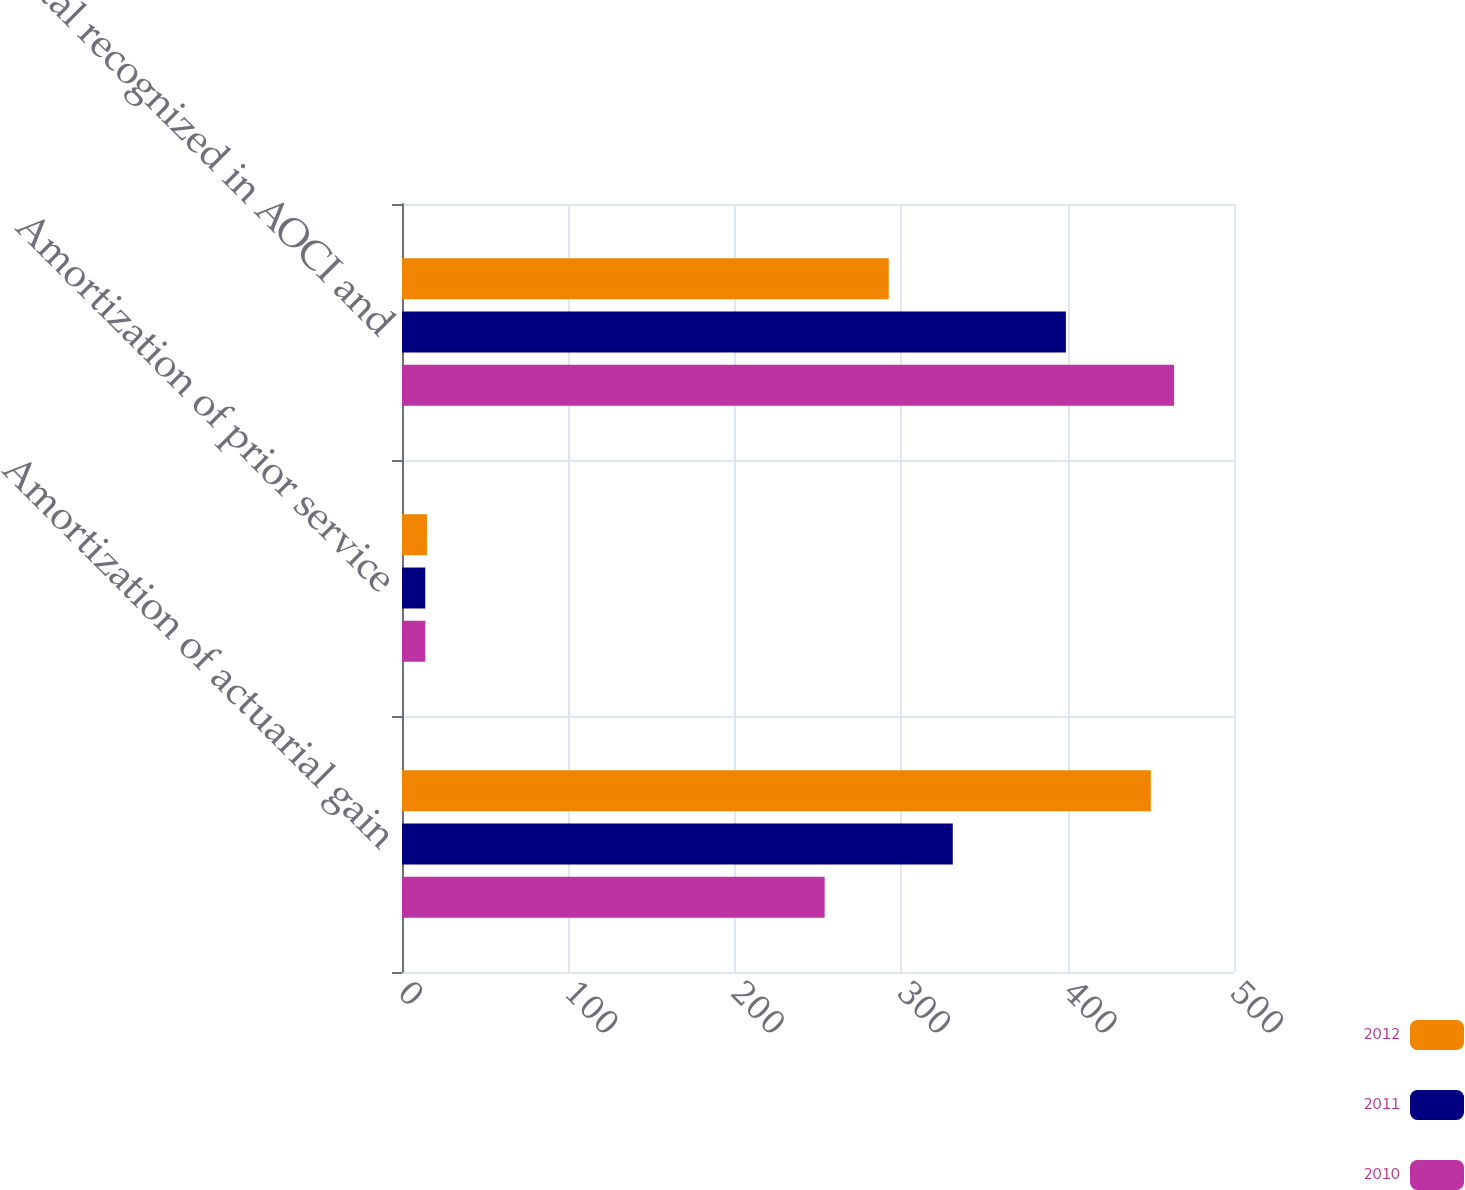Convert chart to OTSL. <chart><loc_0><loc_0><loc_500><loc_500><stacked_bar_chart><ecel><fcel>Amortization of actuarial gain<fcel>Amortization of prior service<fcel>Total recognized in AOCI and<nl><fcel>2012<fcel>450<fcel>15<fcel>292.5<nl><fcel>2011<fcel>331<fcel>14<fcel>399<nl><fcel>2010<fcel>254<fcel>14<fcel>464<nl></chart> 